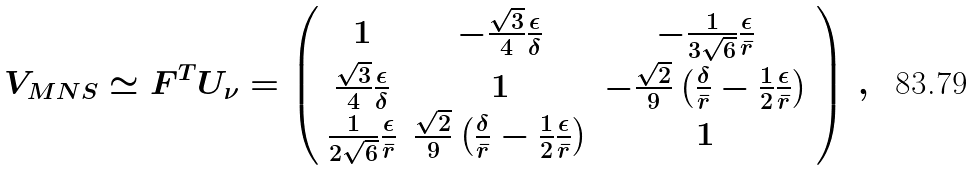Convert formula to latex. <formula><loc_0><loc_0><loc_500><loc_500>V _ { M N S } \simeq F ^ { T } U _ { \nu } = \left ( \begin{array} { c c c } 1 & - \frac { \sqrt { 3 } } { 4 } \frac { \epsilon } { \delta } & - \frac { 1 } { 3 \sqrt { 6 } } \frac { \epsilon } { \bar { r } } \\ \frac { \sqrt { 3 } } { 4 } \frac { \epsilon } { \delta } & 1 & - \frac { \sqrt { 2 } } { 9 } \left ( \frac { \delta } { \bar { r } } - \frac { 1 } { 2 } \frac { \epsilon } { \bar { r } } \right ) \\ \frac { 1 } { 2 \sqrt { 6 } } \frac { \epsilon } { \bar { r } } & \frac { \sqrt { 2 } } { 9 } \left ( \frac { \delta } { \bar { r } } - \frac { 1 } { 2 } \frac { \epsilon } { \bar { r } } \right ) & 1 \\ \end{array} \right ) \, ,</formula> 